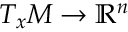Convert formula to latex. <formula><loc_0><loc_0><loc_500><loc_500>T _ { x } M \rightarrow \mathbb { R } ^ { n }</formula> 